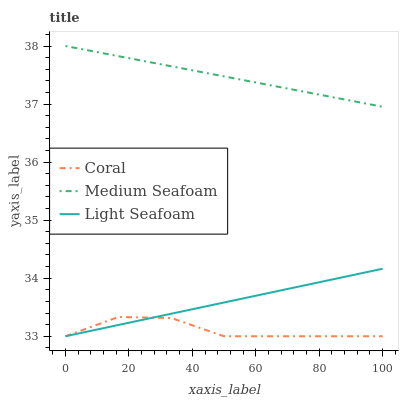Does Coral have the minimum area under the curve?
Answer yes or no. Yes. Does Medium Seafoam have the maximum area under the curve?
Answer yes or no. Yes. Does Light Seafoam have the minimum area under the curve?
Answer yes or no. No. Does Light Seafoam have the maximum area under the curve?
Answer yes or no. No. Is Medium Seafoam the smoothest?
Answer yes or no. Yes. Is Coral the roughest?
Answer yes or no. Yes. Is Light Seafoam the smoothest?
Answer yes or no. No. Is Light Seafoam the roughest?
Answer yes or no. No. Does Coral have the lowest value?
Answer yes or no. Yes. Does Medium Seafoam have the lowest value?
Answer yes or no. No. Does Medium Seafoam have the highest value?
Answer yes or no. Yes. Does Light Seafoam have the highest value?
Answer yes or no. No. Is Light Seafoam less than Medium Seafoam?
Answer yes or no. Yes. Is Medium Seafoam greater than Light Seafoam?
Answer yes or no. Yes. Does Coral intersect Light Seafoam?
Answer yes or no. Yes. Is Coral less than Light Seafoam?
Answer yes or no. No. Is Coral greater than Light Seafoam?
Answer yes or no. No. Does Light Seafoam intersect Medium Seafoam?
Answer yes or no. No. 